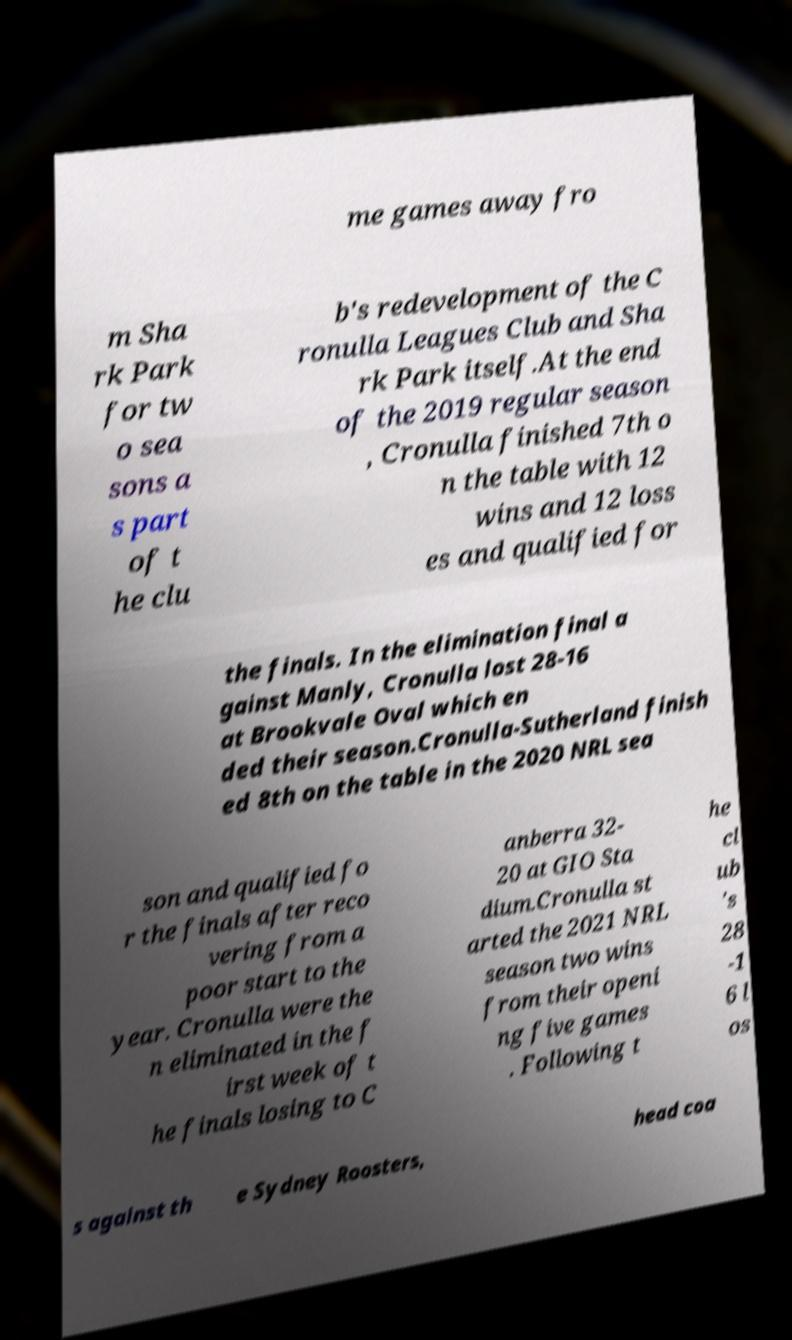Can you read and provide the text displayed in the image?This photo seems to have some interesting text. Can you extract and type it out for me? me games away fro m Sha rk Park for tw o sea sons a s part of t he clu b's redevelopment of the C ronulla Leagues Club and Sha rk Park itself.At the end of the 2019 regular season , Cronulla finished 7th o n the table with 12 wins and 12 loss es and qualified for the finals. In the elimination final a gainst Manly, Cronulla lost 28-16 at Brookvale Oval which en ded their season.Cronulla-Sutherland finish ed 8th on the table in the 2020 NRL sea son and qualified fo r the finals after reco vering from a poor start to the year. Cronulla were the n eliminated in the f irst week of t he finals losing to C anberra 32- 20 at GIO Sta dium.Cronulla st arted the 2021 NRL season two wins from their openi ng five games . Following t he cl ub 's 28 -1 6 l os s against th e Sydney Roosters, head coa 